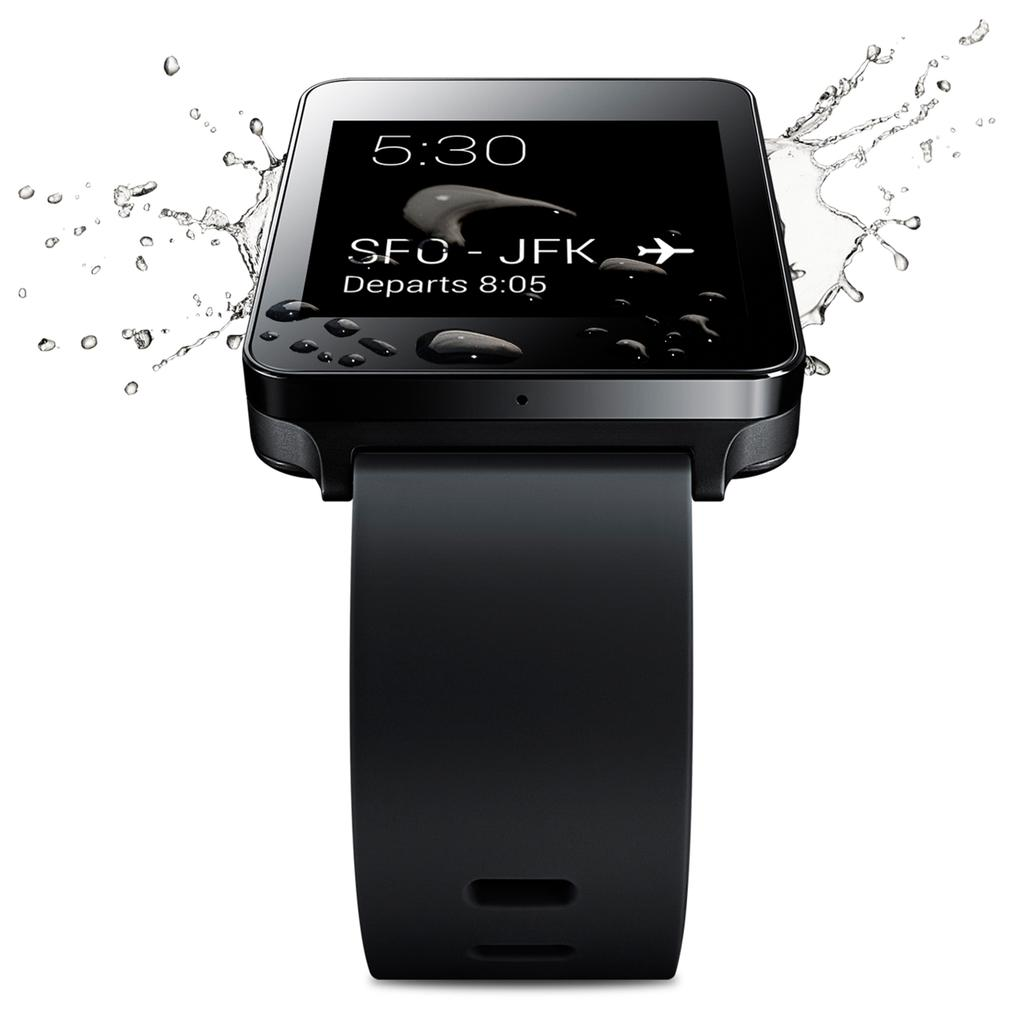Provide a one-sentence caption for the provided image. Flight information on a screen shows a departure time of 8:05. 